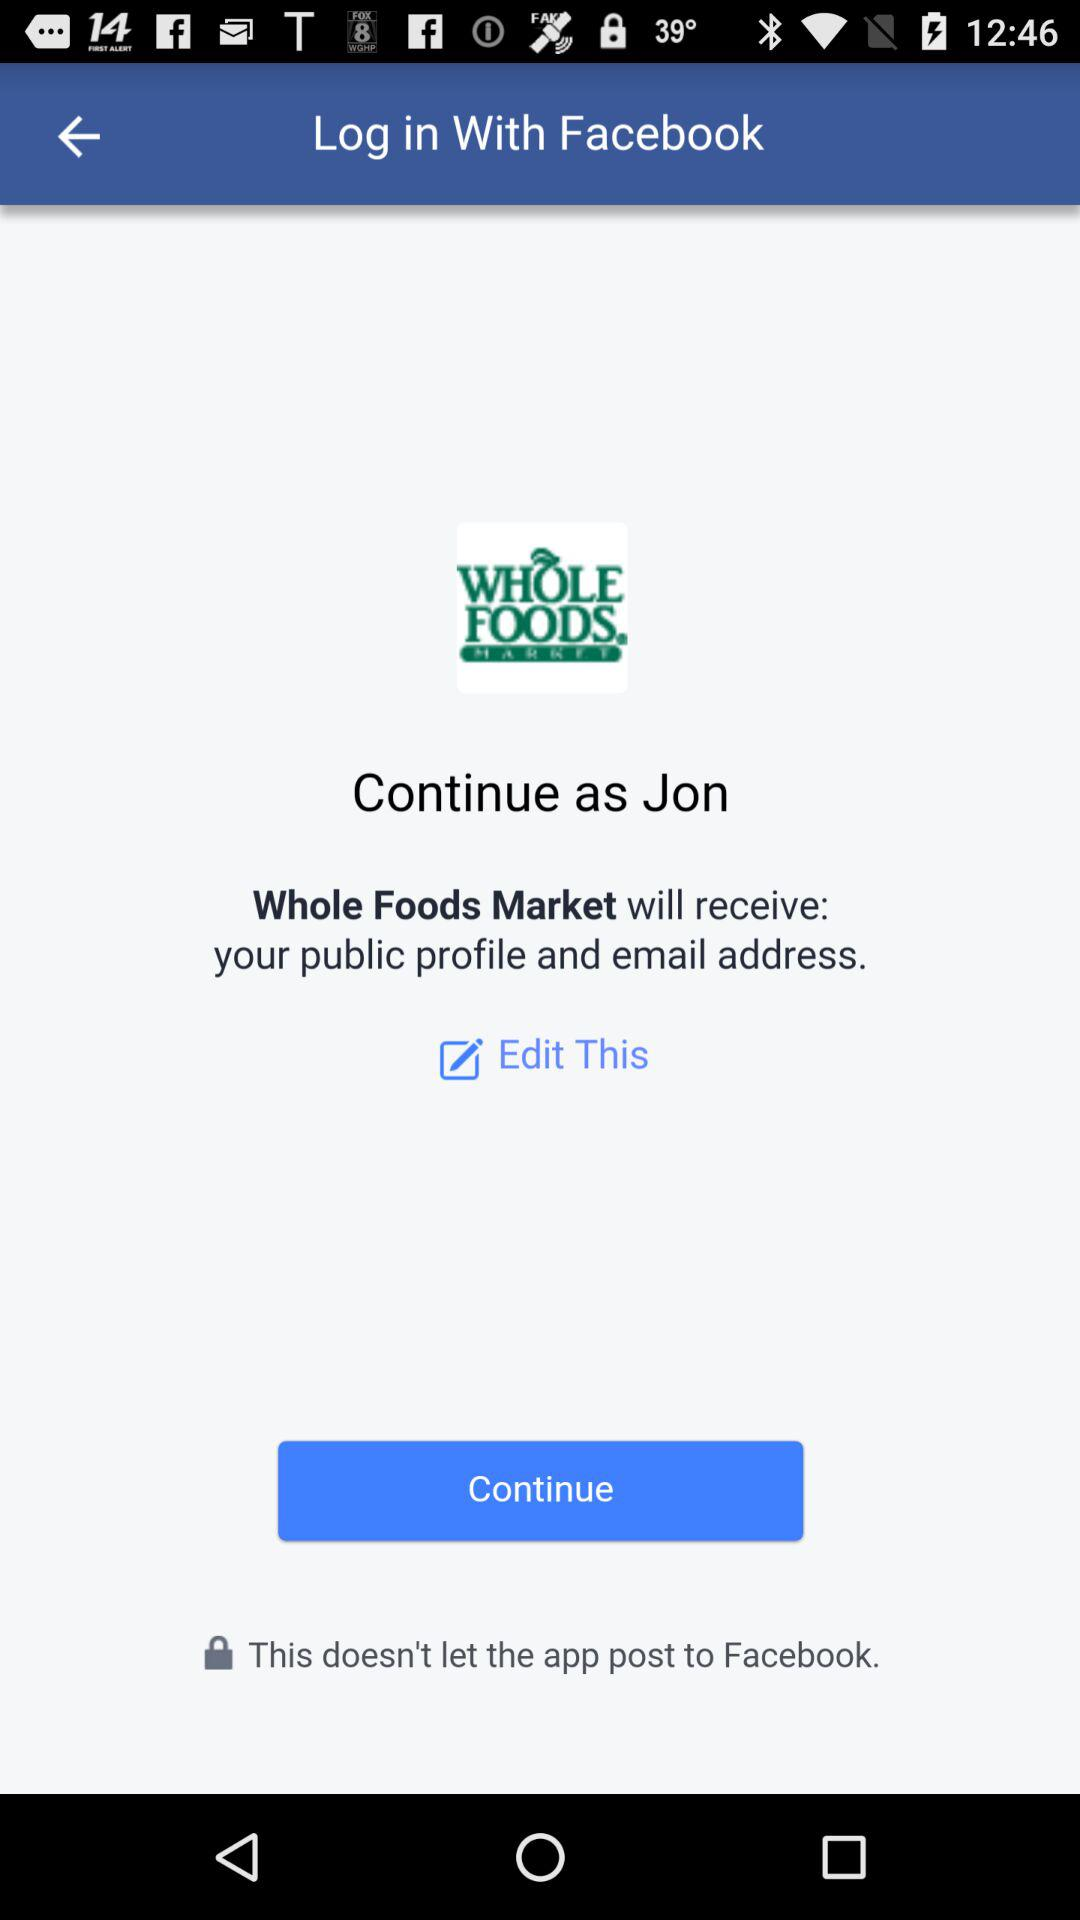What application is used to log in? The application is "Facebook". 